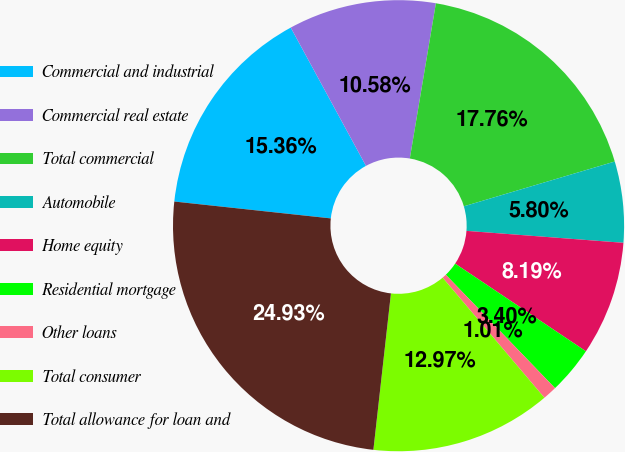<chart> <loc_0><loc_0><loc_500><loc_500><pie_chart><fcel>Commercial and industrial<fcel>Commercial real estate<fcel>Total commercial<fcel>Automobile<fcel>Home equity<fcel>Residential mortgage<fcel>Other loans<fcel>Total consumer<fcel>Total allowance for loan and<nl><fcel>15.36%<fcel>10.58%<fcel>17.76%<fcel>5.8%<fcel>8.19%<fcel>3.4%<fcel>1.01%<fcel>12.97%<fcel>24.93%<nl></chart> 